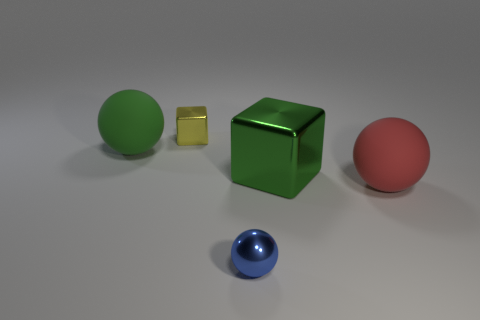Is the material of the small blue object that is in front of the large red matte sphere the same as the large green thing on the left side of the tiny sphere?
Provide a short and direct response. No. What number of objects are big red rubber spheres that are to the right of the tiny metal ball or rubber spheres that are to the right of the yellow shiny thing?
Ensure brevity in your answer.  1. How many green things are there?
Your answer should be very brief. 2. Is there a cube of the same size as the blue object?
Provide a short and direct response. Yes. Is the yellow thing made of the same material as the large ball that is on the right side of the large green matte ball?
Your answer should be very brief. No. What material is the tiny object in front of the large red object?
Keep it short and to the point. Metal. How big is the green rubber object?
Keep it short and to the point. Large. There is a cube that is right of the tiny yellow metal block; is it the same size as the cube that is on the left side of the small sphere?
Give a very brief answer. No. What is the size of the green matte thing that is the same shape as the large red object?
Your response must be concise. Large. There is a yellow metallic cube; is its size the same as the green thing that is on the left side of the tiny block?
Ensure brevity in your answer.  No. 